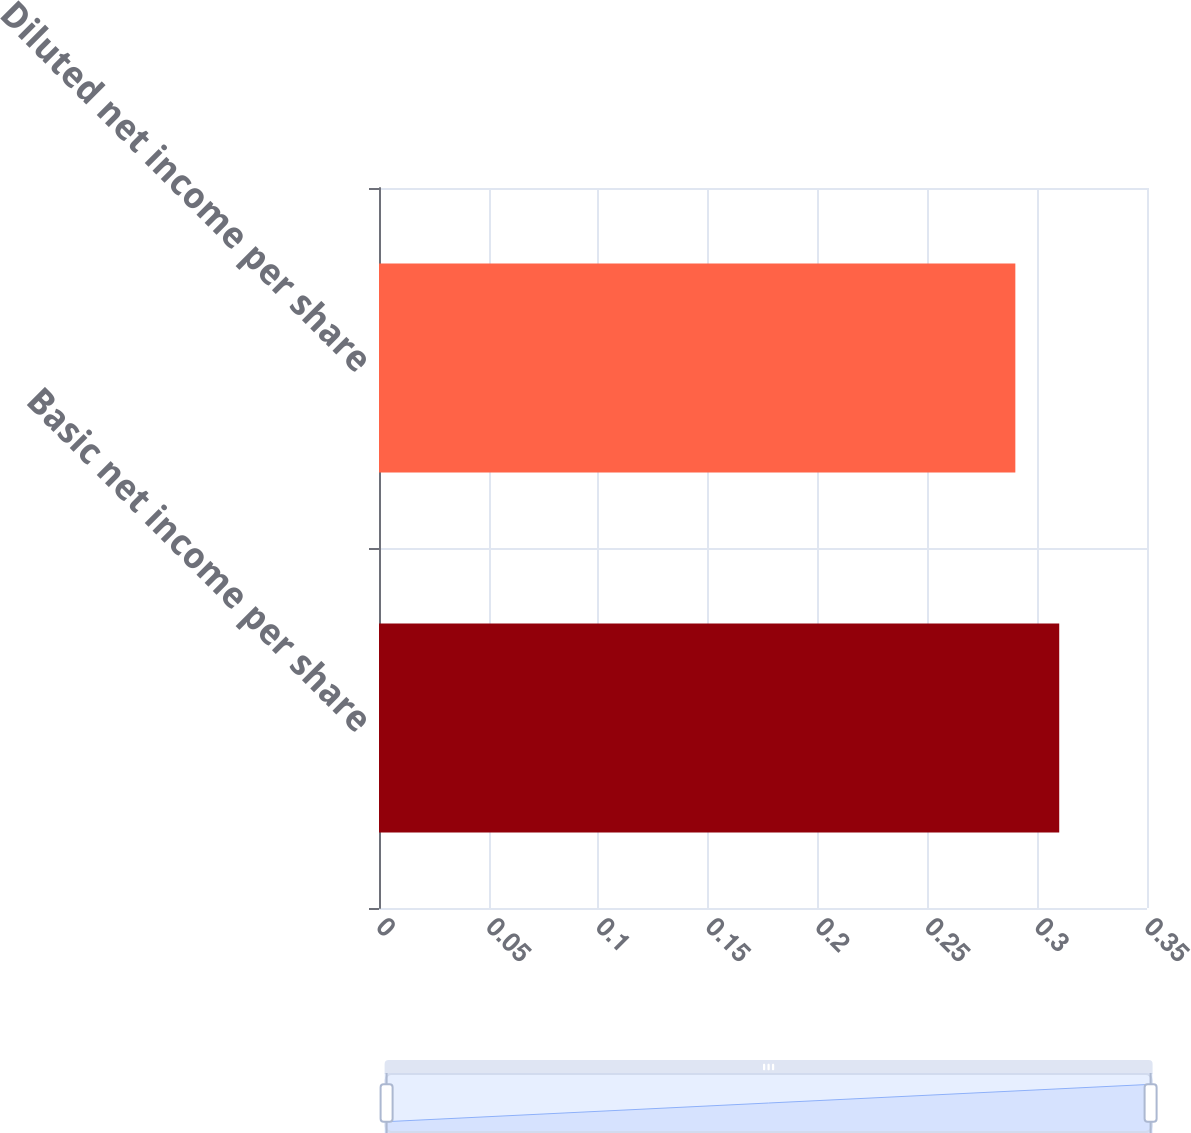Convert chart to OTSL. <chart><loc_0><loc_0><loc_500><loc_500><bar_chart><fcel>Basic net income per share<fcel>Diluted net income per share<nl><fcel>0.31<fcel>0.29<nl></chart> 